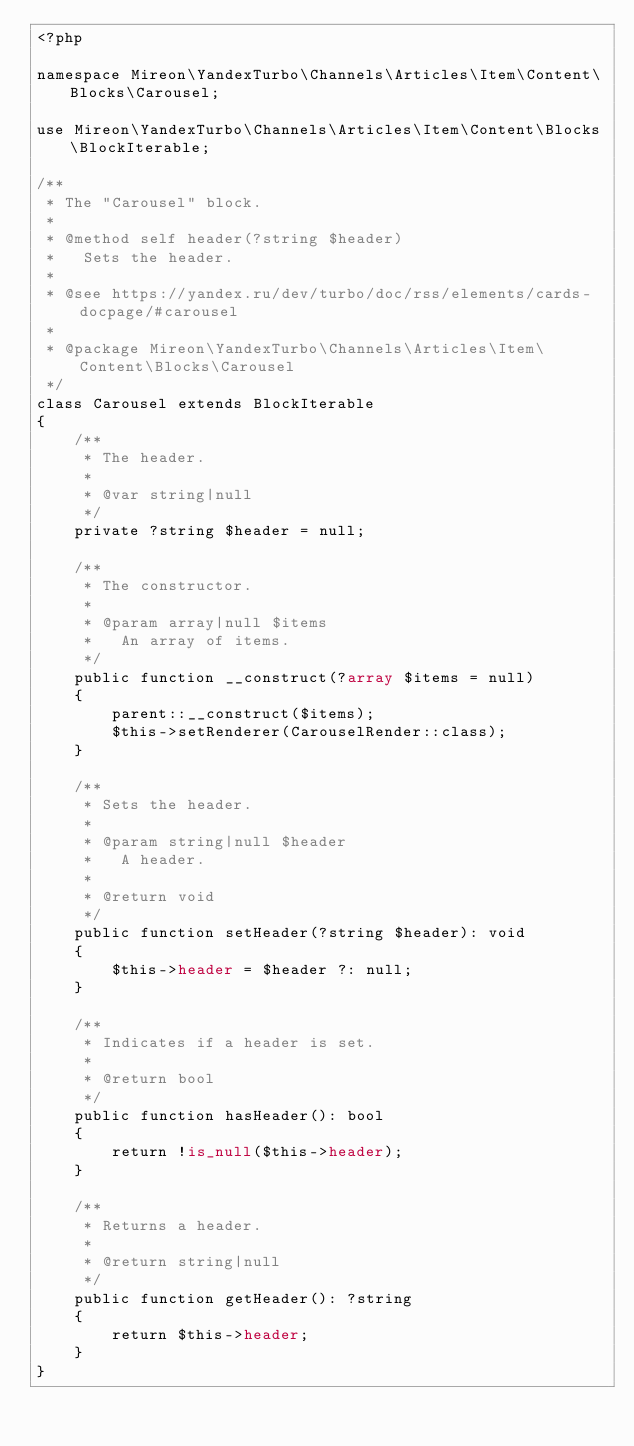Convert code to text. <code><loc_0><loc_0><loc_500><loc_500><_PHP_><?php

namespace Mireon\YandexTurbo\Channels\Articles\Item\Content\Blocks\Carousel;

use Mireon\YandexTurbo\Channels\Articles\Item\Content\Blocks\BlockIterable;

/**
 * The "Carousel" block.
 *
 * @method self header(?string $header)
 *   Sets the header.
 *
 * @see https://yandex.ru/dev/turbo/doc/rss/elements/cards-docpage/#carousel
 *
 * @package Mireon\YandexTurbo\Channels\Articles\Item\Content\Blocks\Carousel
 */
class Carousel extends BlockIterable
{
    /**
     * The header.
     *
     * @var string|null
     */
    private ?string $header = null;

    /**
     * The constructor.
     *
     * @param array|null $items
     *   An array of items.
     */
    public function __construct(?array $items = null)
    {
        parent::__construct($items);
        $this->setRenderer(CarouselRender::class);
    }

    /**
     * Sets the header.
     *
     * @param string|null $header
     *   A header.
     *
     * @return void
     */
    public function setHeader(?string $header): void
    {
        $this->header = $header ?: null;
    }

    /**
     * Indicates if a header is set.
     *
     * @return bool
     */
    public function hasHeader(): bool
    {
        return !is_null($this->header);
    }

    /**
     * Returns a header.
     *
     * @return string|null
     */
    public function getHeader(): ?string
    {
        return $this->header;
    }
}
</code> 